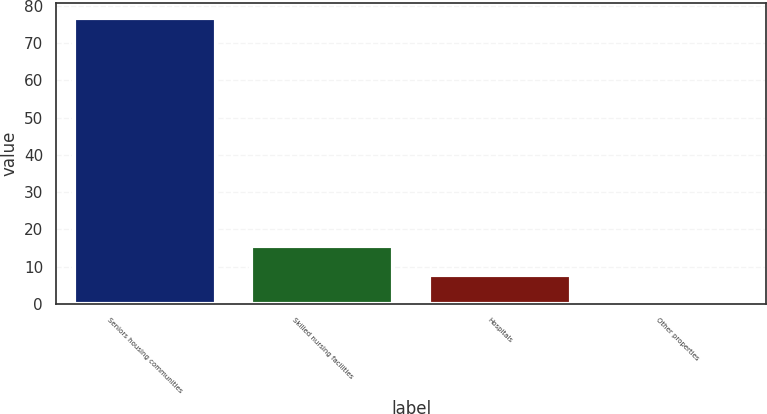<chart> <loc_0><loc_0><loc_500><loc_500><bar_chart><fcel>Seniors housing communities<fcel>Skilled nursing facilities<fcel>Hospitals<fcel>Other properties<nl><fcel>76.9<fcel>15.46<fcel>7.78<fcel>0.1<nl></chart> 